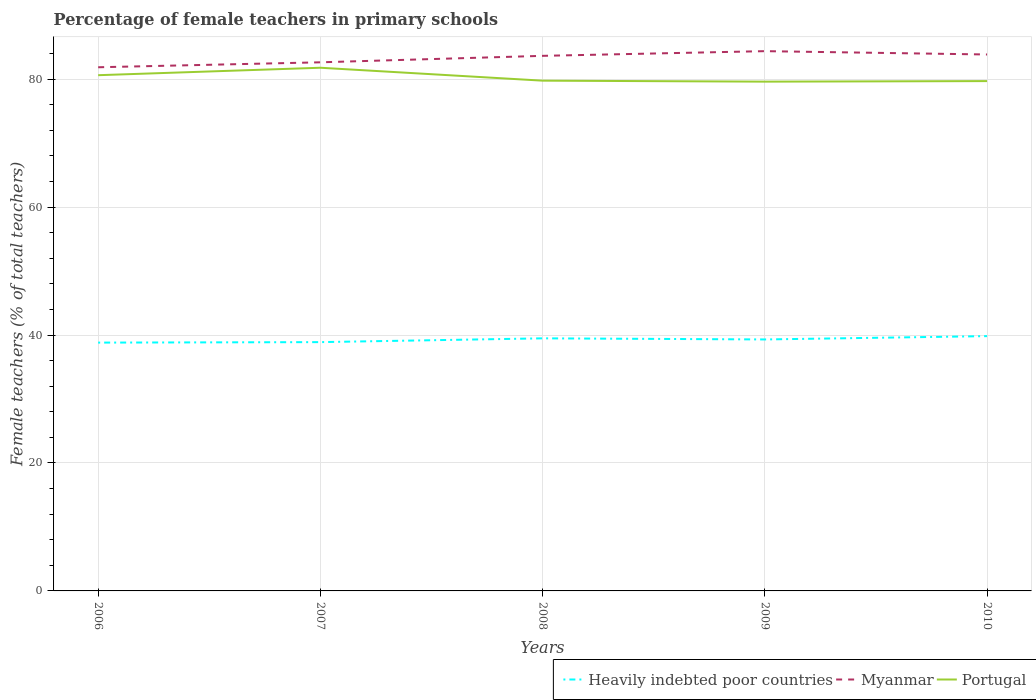Does the line corresponding to Heavily indebted poor countries intersect with the line corresponding to Myanmar?
Offer a very short reply. No. Is the number of lines equal to the number of legend labels?
Provide a short and direct response. Yes. Across all years, what is the maximum percentage of female teachers in Portugal?
Make the answer very short. 79.6. In which year was the percentage of female teachers in Myanmar maximum?
Your response must be concise. 2006. What is the total percentage of female teachers in Portugal in the graph?
Make the answer very short. 2.09. What is the difference between the highest and the second highest percentage of female teachers in Myanmar?
Provide a succinct answer. 2.52. How many lines are there?
Your answer should be compact. 3. What is the difference between two consecutive major ticks on the Y-axis?
Keep it short and to the point. 20. Does the graph contain grids?
Give a very brief answer. Yes. How many legend labels are there?
Ensure brevity in your answer.  3. How are the legend labels stacked?
Provide a succinct answer. Horizontal. What is the title of the graph?
Give a very brief answer. Percentage of female teachers in primary schools. What is the label or title of the X-axis?
Keep it short and to the point. Years. What is the label or title of the Y-axis?
Offer a terse response. Female teachers (% of total teachers). What is the Female teachers (% of total teachers) in Heavily indebted poor countries in 2006?
Your response must be concise. 38.81. What is the Female teachers (% of total teachers) in Myanmar in 2006?
Ensure brevity in your answer.  81.85. What is the Female teachers (% of total teachers) in Portugal in 2006?
Give a very brief answer. 80.61. What is the Female teachers (% of total teachers) in Heavily indebted poor countries in 2007?
Your answer should be very brief. 38.89. What is the Female teachers (% of total teachers) of Myanmar in 2007?
Provide a succinct answer. 82.63. What is the Female teachers (% of total teachers) of Portugal in 2007?
Your answer should be compact. 81.78. What is the Female teachers (% of total teachers) of Heavily indebted poor countries in 2008?
Offer a terse response. 39.48. What is the Female teachers (% of total teachers) of Myanmar in 2008?
Offer a terse response. 83.64. What is the Female teachers (% of total teachers) in Portugal in 2008?
Keep it short and to the point. 79.76. What is the Female teachers (% of total teachers) of Heavily indebted poor countries in 2009?
Keep it short and to the point. 39.31. What is the Female teachers (% of total teachers) of Myanmar in 2009?
Your answer should be compact. 84.37. What is the Female teachers (% of total teachers) of Portugal in 2009?
Ensure brevity in your answer.  79.6. What is the Female teachers (% of total teachers) in Heavily indebted poor countries in 2010?
Provide a succinct answer. 39.83. What is the Female teachers (% of total teachers) of Myanmar in 2010?
Your answer should be compact. 83.85. What is the Female teachers (% of total teachers) in Portugal in 2010?
Ensure brevity in your answer.  79.69. Across all years, what is the maximum Female teachers (% of total teachers) in Heavily indebted poor countries?
Give a very brief answer. 39.83. Across all years, what is the maximum Female teachers (% of total teachers) of Myanmar?
Provide a short and direct response. 84.37. Across all years, what is the maximum Female teachers (% of total teachers) of Portugal?
Your answer should be compact. 81.78. Across all years, what is the minimum Female teachers (% of total teachers) in Heavily indebted poor countries?
Provide a succinct answer. 38.81. Across all years, what is the minimum Female teachers (% of total teachers) of Myanmar?
Your response must be concise. 81.85. Across all years, what is the minimum Female teachers (% of total teachers) in Portugal?
Provide a short and direct response. 79.6. What is the total Female teachers (% of total teachers) of Heavily indebted poor countries in the graph?
Provide a short and direct response. 196.32. What is the total Female teachers (% of total teachers) of Myanmar in the graph?
Keep it short and to the point. 416.33. What is the total Female teachers (% of total teachers) of Portugal in the graph?
Ensure brevity in your answer.  401.44. What is the difference between the Female teachers (% of total teachers) of Heavily indebted poor countries in 2006 and that in 2007?
Give a very brief answer. -0.08. What is the difference between the Female teachers (% of total teachers) in Myanmar in 2006 and that in 2007?
Keep it short and to the point. -0.77. What is the difference between the Female teachers (% of total teachers) in Portugal in 2006 and that in 2007?
Make the answer very short. -1.16. What is the difference between the Female teachers (% of total teachers) of Heavily indebted poor countries in 2006 and that in 2008?
Give a very brief answer. -0.67. What is the difference between the Female teachers (% of total teachers) of Myanmar in 2006 and that in 2008?
Offer a terse response. -1.78. What is the difference between the Female teachers (% of total teachers) of Portugal in 2006 and that in 2008?
Your answer should be compact. 0.85. What is the difference between the Female teachers (% of total teachers) in Heavily indebted poor countries in 2006 and that in 2009?
Keep it short and to the point. -0.49. What is the difference between the Female teachers (% of total teachers) of Myanmar in 2006 and that in 2009?
Ensure brevity in your answer.  -2.52. What is the difference between the Female teachers (% of total teachers) of Portugal in 2006 and that in 2009?
Make the answer very short. 1.01. What is the difference between the Female teachers (% of total teachers) of Heavily indebted poor countries in 2006 and that in 2010?
Offer a terse response. -1.01. What is the difference between the Female teachers (% of total teachers) of Myanmar in 2006 and that in 2010?
Make the answer very short. -2. What is the difference between the Female teachers (% of total teachers) of Portugal in 2006 and that in 2010?
Give a very brief answer. 0.92. What is the difference between the Female teachers (% of total teachers) in Heavily indebted poor countries in 2007 and that in 2008?
Make the answer very short. -0.59. What is the difference between the Female teachers (% of total teachers) in Myanmar in 2007 and that in 2008?
Make the answer very short. -1.01. What is the difference between the Female teachers (% of total teachers) of Portugal in 2007 and that in 2008?
Offer a very short reply. 2.02. What is the difference between the Female teachers (% of total teachers) in Heavily indebted poor countries in 2007 and that in 2009?
Make the answer very short. -0.42. What is the difference between the Female teachers (% of total teachers) of Myanmar in 2007 and that in 2009?
Your answer should be compact. -1.74. What is the difference between the Female teachers (% of total teachers) in Portugal in 2007 and that in 2009?
Make the answer very short. 2.17. What is the difference between the Female teachers (% of total teachers) of Heavily indebted poor countries in 2007 and that in 2010?
Your response must be concise. -0.94. What is the difference between the Female teachers (% of total teachers) of Myanmar in 2007 and that in 2010?
Provide a short and direct response. -1.22. What is the difference between the Female teachers (% of total teachers) in Portugal in 2007 and that in 2010?
Provide a succinct answer. 2.09. What is the difference between the Female teachers (% of total teachers) in Heavily indebted poor countries in 2008 and that in 2009?
Provide a short and direct response. 0.17. What is the difference between the Female teachers (% of total teachers) in Myanmar in 2008 and that in 2009?
Provide a short and direct response. -0.73. What is the difference between the Female teachers (% of total teachers) of Portugal in 2008 and that in 2009?
Offer a terse response. 0.15. What is the difference between the Female teachers (% of total teachers) in Heavily indebted poor countries in 2008 and that in 2010?
Offer a terse response. -0.35. What is the difference between the Female teachers (% of total teachers) of Myanmar in 2008 and that in 2010?
Make the answer very short. -0.21. What is the difference between the Female teachers (% of total teachers) of Portugal in 2008 and that in 2010?
Offer a terse response. 0.07. What is the difference between the Female teachers (% of total teachers) of Heavily indebted poor countries in 2009 and that in 2010?
Ensure brevity in your answer.  -0.52. What is the difference between the Female teachers (% of total teachers) in Myanmar in 2009 and that in 2010?
Make the answer very short. 0.52. What is the difference between the Female teachers (% of total teachers) of Portugal in 2009 and that in 2010?
Give a very brief answer. -0.09. What is the difference between the Female teachers (% of total teachers) of Heavily indebted poor countries in 2006 and the Female teachers (% of total teachers) of Myanmar in 2007?
Provide a succinct answer. -43.81. What is the difference between the Female teachers (% of total teachers) of Heavily indebted poor countries in 2006 and the Female teachers (% of total teachers) of Portugal in 2007?
Offer a terse response. -42.96. What is the difference between the Female teachers (% of total teachers) of Myanmar in 2006 and the Female teachers (% of total teachers) of Portugal in 2007?
Provide a short and direct response. 0.08. What is the difference between the Female teachers (% of total teachers) in Heavily indebted poor countries in 2006 and the Female teachers (% of total teachers) in Myanmar in 2008?
Your answer should be compact. -44.82. What is the difference between the Female teachers (% of total teachers) of Heavily indebted poor countries in 2006 and the Female teachers (% of total teachers) of Portugal in 2008?
Provide a succinct answer. -40.94. What is the difference between the Female teachers (% of total teachers) in Myanmar in 2006 and the Female teachers (% of total teachers) in Portugal in 2008?
Your answer should be very brief. 2.1. What is the difference between the Female teachers (% of total teachers) in Heavily indebted poor countries in 2006 and the Female teachers (% of total teachers) in Myanmar in 2009?
Keep it short and to the point. -45.56. What is the difference between the Female teachers (% of total teachers) of Heavily indebted poor countries in 2006 and the Female teachers (% of total teachers) of Portugal in 2009?
Give a very brief answer. -40.79. What is the difference between the Female teachers (% of total teachers) in Myanmar in 2006 and the Female teachers (% of total teachers) in Portugal in 2009?
Keep it short and to the point. 2.25. What is the difference between the Female teachers (% of total teachers) of Heavily indebted poor countries in 2006 and the Female teachers (% of total teachers) of Myanmar in 2010?
Your response must be concise. -45.04. What is the difference between the Female teachers (% of total teachers) in Heavily indebted poor countries in 2006 and the Female teachers (% of total teachers) in Portugal in 2010?
Your response must be concise. -40.88. What is the difference between the Female teachers (% of total teachers) of Myanmar in 2006 and the Female teachers (% of total teachers) of Portugal in 2010?
Your answer should be very brief. 2.16. What is the difference between the Female teachers (% of total teachers) of Heavily indebted poor countries in 2007 and the Female teachers (% of total teachers) of Myanmar in 2008?
Your response must be concise. -44.75. What is the difference between the Female teachers (% of total teachers) of Heavily indebted poor countries in 2007 and the Female teachers (% of total teachers) of Portugal in 2008?
Your answer should be compact. -40.87. What is the difference between the Female teachers (% of total teachers) in Myanmar in 2007 and the Female teachers (% of total teachers) in Portugal in 2008?
Your response must be concise. 2.87. What is the difference between the Female teachers (% of total teachers) in Heavily indebted poor countries in 2007 and the Female teachers (% of total teachers) in Myanmar in 2009?
Your answer should be compact. -45.48. What is the difference between the Female teachers (% of total teachers) of Heavily indebted poor countries in 2007 and the Female teachers (% of total teachers) of Portugal in 2009?
Offer a terse response. -40.71. What is the difference between the Female teachers (% of total teachers) of Myanmar in 2007 and the Female teachers (% of total teachers) of Portugal in 2009?
Your answer should be compact. 3.02. What is the difference between the Female teachers (% of total teachers) in Heavily indebted poor countries in 2007 and the Female teachers (% of total teachers) in Myanmar in 2010?
Make the answer very short. -44.96. What is the difference between the Female teachers (% of total teachers) of Heavily indebted poor countries in 2007 and the Female teachers (% of total teachers) of Portugal in 2010?
Keep it short and to the point. -40.8. What is the difference between the Female teachers (% of total teachers) of Myanmar in 2007 and the Female teachers (% of total teachers) of Portugal in 2010?
Your answer should be very brief. 2.94. What is the difference between the Female teachers (% of total teachers) of Heavily indebted poor countries in 2008 and the Female teachers (% of total teachers) of Myanmar in 2009?
Give a very brief answer. -44.89. What is the difference between the Female teachers (% of total teachers) in Heavily indebted poor countries in 2008 and the Female teachers (% of total teachers) in Portugal in 2009?
Provide a succinct answer. -40.12. What is the difference between the Female teachers (% of total teachers) of Myanmar in 2008 and the Female teachers (% of total teachers) of Portugal in 2009?
Provide a short and direct response. 4.03. What is the difference between the Female teachers (% of total teachers) of Heavily indebted poor countries in 2008 and the Female teachers (% of total teachers) of Myanmar in 2010?
Provide a succinct answer. -44.37. What is the difference between the Female teachers (% of total teachers) in Heavily indebted poor countries in 2008 and the Female teachers (% of total teachers) in Portugal in 2010?
Offer a very short reply. -40.21. What is the difference between the Female teachers (% of total teachers) in Myanmar in 2008 and the Female teachers (% of total teachers) in Portugal in 2010?
Your answer should be compact. 3.95. What is the difference between the Female teachers (% of total teachers) of Heavily indebted poor countries in 2009 and the Female teachers (% of total teachers) of Myanmar in 2010?
Offer a terse response. -44.54. What is the difference between the Female teachers (% of total teachers) in Heavily indebted poor countries in 2009 and the Female teachers (% of total teachers) in Portugal in 2010?
Offer a very short reply. -40.38. What is the difference between the Female teachers (% of total teachers) of Myanmar in 2009 and the Female teachers (% of total teachers) of Portugal in 2010?
Make the answer very short. 4.68. What is the average Female teachers (% of total teachers) of Heavily indebted poor countries per year?
Provide a short and direct response. 39.26. What is the average Female teachers (% of total teachers) in Myanmar per year?
Give a very brief answer. 83.27. What is the average Female teachers (% of total teachers) in Portugal per year?
Give a very brief answer. 80.29. In the year 2006, what is the difference between the Female teachers (% of total teachers) of Heavily indebted poor countries and Female teachers (% of total teachers) of Myanmar?
Your response must be concise. -43.04. In the year 2006, what is the difference between the Female teachers (% of total teachers) of Heavily indebted poor countries and Female teachers (% of total teachers) of Portugal?
Your answer should be compact. -41.8. In the year 2006, what is the difference between the Female teachers (% of total teachers) in Myanmar and Female teachers (% of total teachers) in Portugal?
Provide a succinct answer. 1.24. In the year 2007, what is the difference between the Female teachers (% of total teachers) of Heavily indebted poor countries and Female teachers (% of total teachers) of Myanmar?
Give a very brief answer. -43.74. In the year 2007, what is the difference between the Female teachers (% of total teachers) of Heavily indebted poor countries and Female teachers (% of total teachers) of Portugal?
Provide a succinct answer. -42.89. In the year 2007, what is the difference between the Female teachers (% of total teachers) of Myanmar and Female teachers (% of total teachers) of Portugal?
Provide a succinct answer. 0.85. In the year 2008, what is the difference between the Female teachers (% of total teachers) in Heavily indebted poor countries and Female teachers (% of total teachers) in Myanmar?
Your answer should be very brief. -44.16. In the year 2008, what is the difference between the Female teachers (% of total teachers) in Heavily indebted poor countries and Female teachers (% of total teachers) in Portugal?
Ensure brevity in your answer.  -40.28. In the year 2008, what is the difference between the Female teachers (% of total teachers) in Myanmar and Female teachers (% of total teachers) in Portugal?
Your response must be concise. 3.88. In the year 2009, what is the difference between the Female teachers (% of total teachers) in Heavily indebted poor countries and Female teachers (% of total teachers) in Myanmar?
Offer a terse response. -45.06. In the year 2009, what is the difference between the Female teachers (% of total teachers) in Heavily indebted poor countries and Female teachers (% of total teachers) in Portugal?
Your answer should be compact. -40.3. In the year 2009, what is the difference between the Female teachers (% of total teachers) in Myanmar and Female teachers (% of total teachers) in Portugal?
Provide a succinct answer. 4.77. In the year 2010, what is the difference between the Female teachers (% of total teachers) of Heavily indebted poor countries and Female teachers (% of total teachers) of Myanmar?
Offer a very short reply. -44.02. In the year 2010, what is the difference between the Female teachers (% of total teachers) of Heavily indebted poor countries and Female teachers (% of total teachers) of Portugal?
Provide a succinct answer. -39.86. In the year 2010, what is the difference between the Female teachers (% of total teachers) of Myanmar and Female teachers (% of total teachers) of Portugal?
Your response must be concise. 4.16. What is the ratio of the Female teachers (% of total teachers) in Heavily indebted poor countries in 2006 to that in 2007?
Your answer should be very brief. 1. What is the ratio of the Female teachers (% of total teachers) of Myanmar in 2006 to that in 2007?
Give a very brief answer. 0.99. What is the ratio of the Female teachers (% of total teachers) of Portugal in 2006 to that in 2007?
Provide a short and direct response. 0.99. What is the ratio of the Female teachers (% of total teachers) of Heavily indebted poor countries in 2006 to that in 2008?
Offer a terse response. 0.98. What is the ratio of the Female teachers (% of total teachers) in Myanmar in 2006 to that in 2008?
Ensure brevity in your answer.  0.98. What is the ratio of the Female teachers (% of total teachers) of Portugal in 2006 to that in 2008?
Offer a very short reply. 1.01. What is the ratio of the Female teachers (% of total teachers) of Heavily indebted poor countries in 2006 to that in 2009?
Provide a short and direct response. 0.99. What is the ratio of the Female teachers (% of total teachers) of Myanmar in 2006 to that in 2009?
Make the answer very short. 0.97. What is the ratio of the Female teachers (% of total teachers) in Portugal in 2006 to that in 2009?
Offer a very short reply. 1.01. What is the ratio of the Female teachers (% of total teachers) in Heavily indebted poor countries in 2006 to that in 2010?
Make the answer very short. 0.97. What is the ratio of the Female teachers (% of total teachers) of Myanmar in 2006 to that in 2010?
Ensure brevity in your answer.  0.98. What is the ratio of the Female teachers (% of total teachers) in Portugal in 2006 to that in 2010?
Offer a very short reply. 1.01. What is the ratio of the Female teachers (% of total teachers) in Myanmar in 2007 to that in 2008?
Ensure brevity in your answer.  0.99. What is the ratio of the Female teachers (% of total teachers) of Portugal in 2007 to that in 2008?
Keep it short and to the point. 1.03. What is the ratio of the Female teachers (% of total teachers) of Heavily indebted poor countries in 2007 to that in 2009?
Give a very brief answer. 0.99. What is the ratio of the Female teachers (% of total teachers) in Myanmar in 2007 to that in 2009?
Provide a short and direct response. 0.98. What is the ratio of the Female teachers (% of total teachers) in Portugal in 2007 to that in 2009?
Ensure brevity in your answer.  1.03. What is the ratio of the Female teachers (% of total teachers) in Heavily indebted poor countries in 2007 to that in 2010?
Give a very brief answer. 0.98. What is the ratio of the Female teachers (% of total teachers) of Myanmar in 2007 to that in 2010?
Offer a very short reply. 0.99. What is the ratio of the Female teachers (% of total teachers) of Portugal in 2007 to that in 2010?
Ensure brevity in your answer.  1.03. What is the ratio of the Female teachers (% of total teachers) of Heavily indebted poor countries in 2008 to that in 2009?
Offer a very short reply. 1. What is the ratio of the Female teachers (% of total teachers) of Portugal in 2008 to that in 2009?
Offer a very short reply. 1. What is the ratio of the Female teachers (% of total teachers) in Heavily indebted poor countries in 2008 to that in 2010?
Your answer should be very brief. 0.99. What is the ratio of the Female teachers (% of total teachers) of Heavily indebted poor countries in 2009 to that in 2010?
Your answer should be very brief. 0.99. What is the difference between the highest and the second highest Female teachers (% of total teachers) of Heavily indebted poor countries?
Give a very brief answer. 0.35. What is the difference between the highest and the second highest Female teachers (% of total teachers) of Myanmar?
Make the answer very short. 0.52. What is the difference between the highest and the second highest Female teachers (% of total teachers) of Portugal?
Your answer should be compact. 1.16. What is the difference between the highest and the lowest Female teachers (% of total teachers) of Heavily indebted poor countries?
Give a very brief answer. 1.01. What is the difference between the highest and the lowest Female teachers (% of total teachers) of Myanmar?
Your answer should be compact. 2.52. What is the difference between the highest and the lowest Female teachers (% of total teachers) in Portugal?
Offer a terse response. 2.17. 